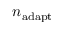<formula> <loc_0><loc_0><loc_500><loc_500>n _ { a d a p t }</formula> 